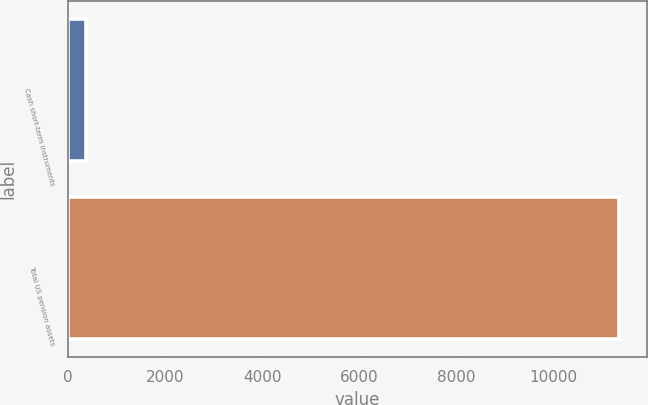Convert chart to OTSL. <chart><loc_0><loc_0><loc_500><loc_500><bar_chart><fcel>Cash short-term instruments<fcel>Total US pension assets<nl><fcel>364<fcel>11354<nl></chart> 